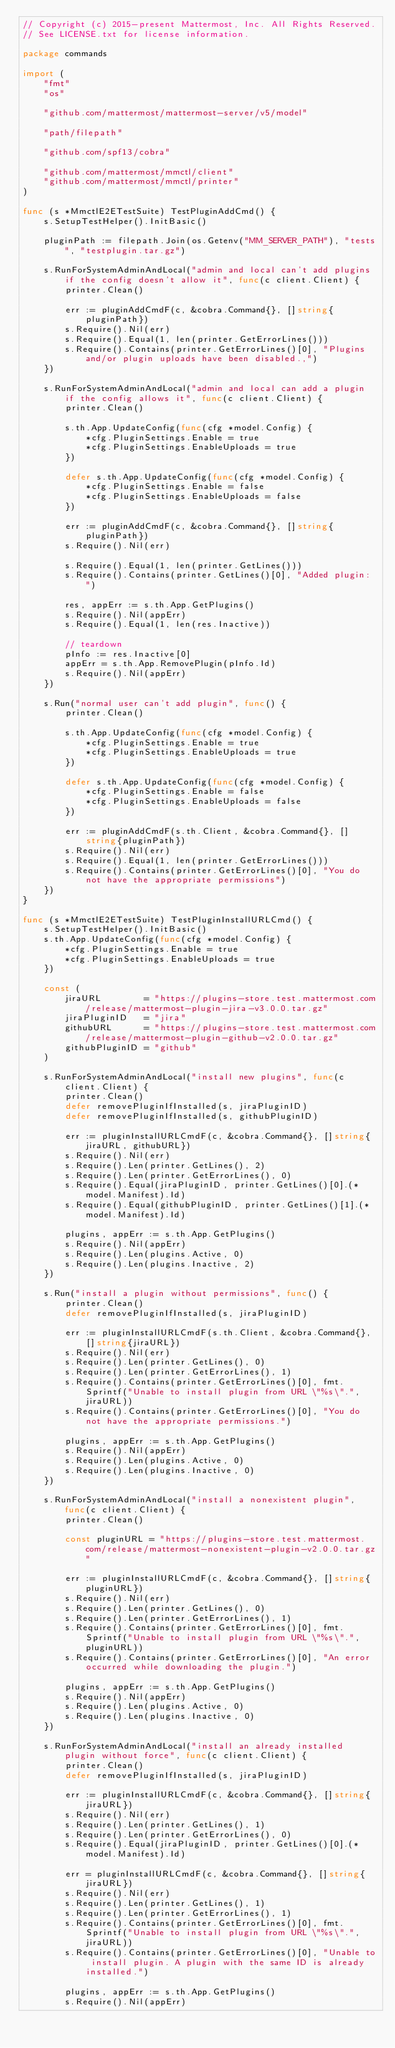<code> <loc_0><loc_0><loc_500><loc_500><_Go_>// Copyright (c) 2015-present Mattermost, Inc. All Rights Reserved.
// See LICENSE.txt for license information.

package commands

import (
	"fmt"
	"os"

	"github.com/mattermost/mattermost-server/v5/model"

	"path/filepath"

	"github.com/spf13/cobra"

	"github.com/mattermost/mmctl/client"
	"github.com/mattermost/mmctl/printer"
)

func (s *MmctlE2ETestSuite) TestPluginAddCmd() {
	s.SetupTestHelper().InitBasic()

	pluginPath := filepath.Join(os.Getenv("MM_SERVER_PATH"), "tests", "testplugin.tar.gz")

	s.RunForSystemAdminAndLocal("admin and local can't add plugins if the config doesn't allow it", func(c client.Client) {
		printer.Clean()

		err := pluginAddCmdF(c, &cobra.Command{}, []string{pluginPath})
		s.Require().Nil(err)
		s.Require().Equal(1, len(printer.GetErrorLines()))
		s.Require().Contains(printer.GetErrorLines()[0], "Plugins and/or plugin uploads have been disabled.,")
	})

	s.RunForSystemAdminAndLocal("admin and local can add a plugin if the config allows it", func(c client.Client) {
		printer.Clean()

		s.th.App.UpdateConfig(func(cfg *model.Config) {
			*cfg.PluginSettings.Enable = true
			*cfg.PluginSettings.EnableUploads = true
		})

		defer s.th.App.UpdateConfig(func(cfg *model.Config) {
			*cfg.PluginSettings.Enable = false
			*cfg.PluginSettings.EnableUploads = false
		})

		err := pluginAddCmdF(c, &cobra.Command{}, []string{pluginPath})
		s.Require().Nil(err)

		s.Require().Equal(1, len(printer.GetLines()))
		s.Require().Contains(printer.GetLines()[0], "Added plugin: ")

		res, appErr := s.th.App.GetPlugins()
		s.Require().Nil(appErr)
		s.Require().Equal(1, len(res.Inactive))

		// teardown
		pInfo := res.Inactive[0]
		appErr = s.th.App.RemovePlugin(pInfo.Id)
		s.Require().Nil(appErr)
	})

	s.Run("normal user can't add plugin", func() {
		printer.Clean()

		s.th.App.UpdateConfig(func(cfg *model.Config) {
			*cfg.PluginSettings.Enable = true
			*cfg.PluginSettings.EnableUploads = true
		})

		defer s.th.App.UpdateConfig(func(cfg *model.Config) {
			*cfg.PluginSettings.Enable = false
			*cfg.PluginSettings.EnableUploads = false
		})

		err := pluginAddCmdF(s.th.Client, &cobra.Command{}, []string{pluginPath})
		s.Require().Nil(err)
		s.Require().Equal(1, len(printer.GetErrorLines()))
		s.Require().Contains(printer.GetErrorLines()[0], "You do not have the appropriate permissions")
	})
}

func (s *MmctlE2ETestSuite) TestPluginInstallURLCmd() {
	s.SetupTestHelper().InitBasic()
	s.th.App.UpdateConfig(func(cfg *model.Config) {
		*cfg.PluginSettings.Enable = true
		*cfg.PluginSettings.EnableUploads = true
	})

	const (
		jiraURL        = "https://plugins-store.test.mattermost.com/release/mattermost-plugin-jira-v3.0.0.tar.gz"
		jiraPluginID   = "jira"
		githubURL      = "https://plugins-store.test.mattermost.com/release/mattermost-plugin-github-v2.0.0.tar.gz"
		githubPluginID = "github"
	)

	s.RunForSystemAdminAndLocal("install new plugins", func(c client.Client) {
		printer.Clean()
		defer removePluginIfInstalled(s, jiraPluginID)
		defer removePluginIfInstalled(s, githubPluginID)

		err := pluginInstallURLCmdF(c, &cobra.Command{}, []string{jiraURL, githubURL})
		s.Require().Nil(err)
		s.Require().Len(printer.GetLines(), 2)
		s.Require().Len(printer.GetErrorLines(), 0)
		s.Require().Equal(jiraPluginID, printer.GetLines()[0].(*model.Manifest).Id)
		s.Require().Equal(githubPluginID, printer.GetLines()[1].(*model.Manifest).Id)

		plugins, appErr := s.th.App.GetPlugins()
		s.Require().Nil(appErr)
		s.Require().Len(plugins.Active, 0)
		s.Require().Len(plugins.Inactive, 2)
	})

	s.Run("install a plugin without permissions", func() {
		printer.Clean()
		defer removePluginIfInstalled(s, jiraPluginID)

		err := pluginInstallURLCmdF(s.th.Client, &cobra.Command{}, []string{jiraURL})
		s.Require().Nil(err)
		s.Require().Len(printer.GetLines(), 0)
		s.Require().Len(printer.GetErrorLines(), 1)
		s.Require().Contains(printer.GetErrorLines()[0], fmt.Sprintf("Unable to install plugin from URL \"%s\".", jiraURL))
		s.Require().Contains(printer.GetErrorLines()[0], "You do not have the appropriate permissions.")

		plugins, appErr := s.th.App.GetPlugins()
		s.Require().Nil(appErr)
		s.Require().Len(plugins.Active, 0)
		s.Require().Len(plugins.Inactive, 0)
	})

	s.RunForSystemAdminAndLocal("install a nonexistent plugin", func(c client.Client) {
		printer.Clean()

		const pluginURL = "https://plugins-store.test.mattermost.com/release/mattermost-nonexistent-plugin-v2.0.0.tar.gz"

		err := pluginInstallURLCmdF(c, &cobra.Command{}, []string{pluginURL})
		s.Require().Nil(err)
		s.Require().Len(printer.GetLines(), 0)
		s.Require().Len(printer.GetErrorLines(), 1)
		s.Require().Contains(printer.GetErrorLines()[0], fmt.Sprintf("Unable to install plugin from URL \"%s\".", pluginURL))
		s.Require().Contains(printer.GetErrorLines()[0], "An error occurred while downloading the plugin.")

		plugins, appErr := s.th.App.GetPlugins()
		s.Require().Nil(appErr)
		s.Require().Len(plugins.Active, 0)
		s.Require().Len(plugins.Inactive, 0)
	})

	s.RunForSystemAdminAndLocal("install an already installed plugin without force", func(c client.Client) {
		printer.Clean()
		defer removePluginIfInstalled(s, jiraPluginID)

		err := pluginInstallURLCmdF(c, &cobra.Command{}, []string{jiraURL})
		s.Require().Nil(err)
		s.Require().Len(printer.GetLines(), 1)
		s.Require().Len(printer.GetErrorLines(), 0)
		s.Require().Equal(jiraPluginID, printer.GetLines()[0].(*model.Manifest).Id)

		err = pluginInstallURLCmdF(c, &cobra.Command{}, []string{jiraURL})
		s.Require().Nil(err)
		s.Require().Len(printer.GetLines(), 1)
		s.Require().Len(printer.GetErrorLines(), 1)
		s.Require().Contains(printer.GetErrorLines()[0], fmt.Sprintf("Unable to install plugin from URL \"%s\".", jiraURL))
		s.Require().Contains(printer.GetErrorLines()[0], "Unable to install plugin. A plugin with the same ID is already installed.")

		plugins, appErr := s.th.App.GetPlugins()
		s.Require().Nil(appErr)</code> 